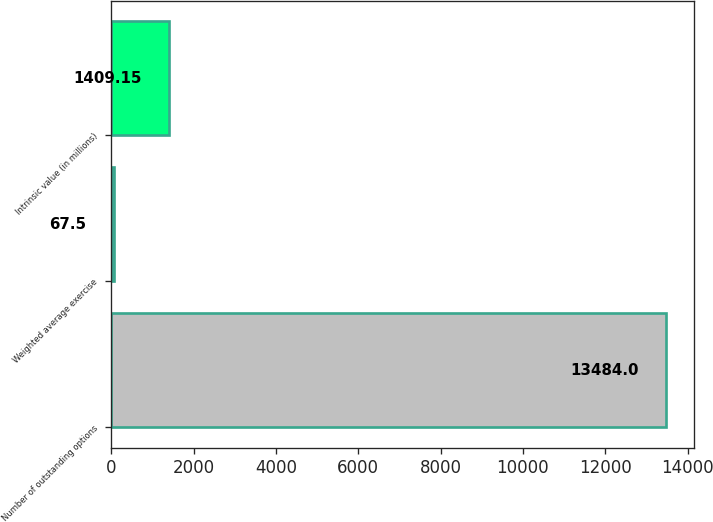Convert chart. <chart><loc_0><loc_0><loc_500><loc_500><bar_chart><fcel>Number of outstanding options<fcel>Weighted average exercise<fcel>Intrinsic value (in millions)<nl><fcel>13484<fcel>67.5<fcel>1409.15<nl></chart> 